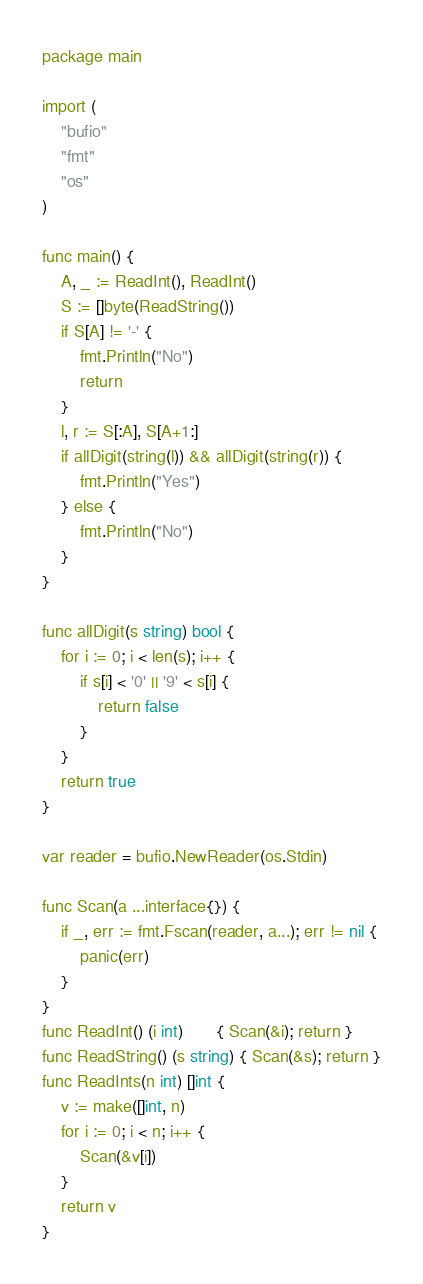<code> <loc_0><loc_0><loc_500><loc_500><_Go_>package main

import (
	"bufio"
	"fmt"
	"os"
)

func main() {
	A, _ := ReadInt(), ReadInt()
	S := []byte(ReadString())
	if S[A] != '-' {
		fmt.Println("No")
		return
	}
	l, r := S[:A], S[A+1:]
	if allDigit(string(l)) && allDigit(string(r)) {
		fmt.Println("Yes")
	} else {
		fmt.Println("No")
	}
}

func allDigit(s string) bool {
	for i := 0; i < len(s); i++ {
		if s[i] < '0' || '9' < s[i] {
			return false
		}
	}
	return true
}

var reader = bufio.NewReader(os.Stdin)

func Scan(a ...interface{}) {
	if _, err := fmt.Fscan(reader, a...); err != nil {
		panic(err)
	}
}
func ReadInt() (i int)       { Scan(&i); return }
func ReadString() (s string) { Scan(&s); return }
func ReadInts(n int) []int {
	v := make([]int, n)
	for i := 0; i < n; i++ {
		Scan(&v[i])
	}
	return v
}
</code> 